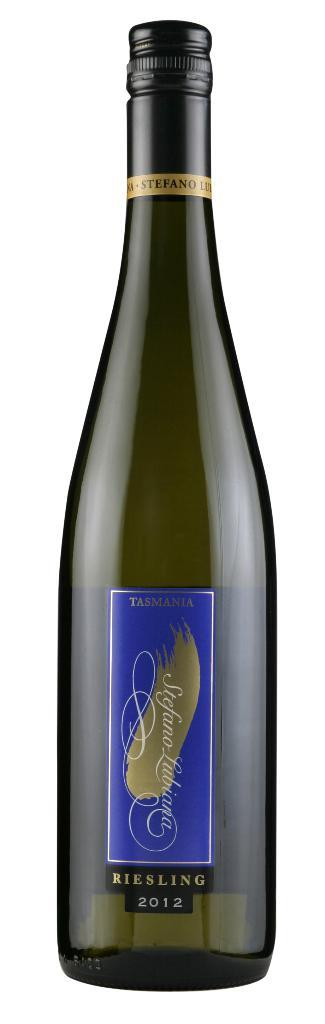Provide a one-sentence caption for the provided image. There's nothing like an unopened bottle of Riesling 2012. 